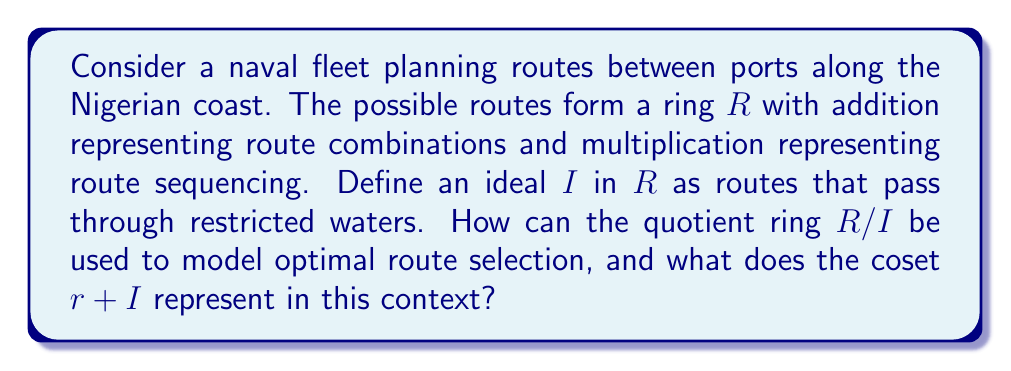Give your solution to this math problem. To understand how the quotient ring $R/I$ can be used to model optimal route selection and what the coset $r + I$ represents, let's break down the problem step-by-step:

1) Ring Structure:
   The ring $R$ represents all possible routes between ports. 
   - Addition in $R$: Combining different routes
   - Multiplication in $R$: Sequencing routes

2) Ideal $I$:
   The ideal $I$ consists of all routes that pass through restricted waters. These are routes that should be avoided in optimal planning.

3) Quotient Ring $R/I$:
   The quotient ring $R/I$ represents the set of all cosets of $I$ in $R$. Each coset can be thought of as an equivalence class of routes.

4) Coset Representation:
   A coset $r + I$ represents all routes that differ from $r$ by a route through restricted waters. In other words, $r + I$ contains all routes that are "equivalent" to $r$ when we ignore differences that involve restricted waters.

5) Optimal Route Selection:
   The quotient ring $R/I$ provides a way to model optimal route selection by:
   a) Simplifying the route space: Instead of considering all possible routes, we only need to consider representatives from each coset.
   b) Automatically avoiding restricted waters: Any route in a given coset will be optimal with respect to avoiding restricted waters.
   c) Preserving essential differences: Routes that differ in important ways (i.e., not just by passing through different restricted areas) will be in different cosets.

6) Operations in $R/I$:
   - Addition in $R/I$ represents combining optimal route plans while automatically avoiding restricted waters.
   - Multiplication in $R/I$ represents sequencing optimal route plans.

7) Practical Application:
   Naval officers can work with elements of $R/I$ to plan routes, knowing that:
   - Each element represents a class of equivalent routes
   - Operations on these elements will always result in optimal routes (with respect to avoiding restricted waters)
   - The structure preserves important relationships between routes while simplifying the planning process
Answer: The quotient ring $R/I$ models optimal route selection by simplifying the route space, automatically avoiding restricted waters, and preserving essential differences between routes. The coset $r + I$ represents all routes that are equivalent to $r$ when differences involving restricted waters are ignored, effectively grouping together routes that are optimal alternatives to each other. 